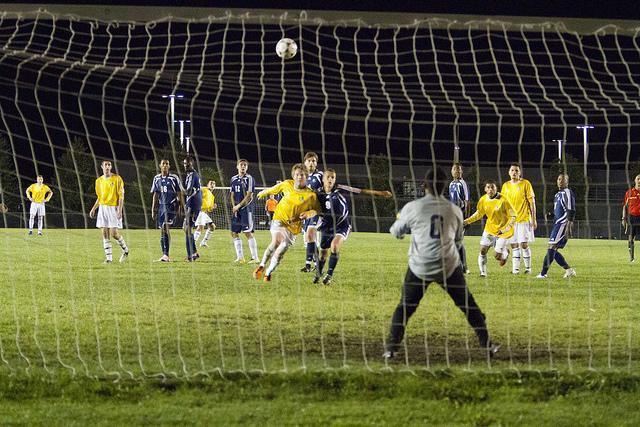How many out of fifteen people are wearing yellow?
Give a very brief answer. 6. How many people are there?
Give a very brief answer. 9. 